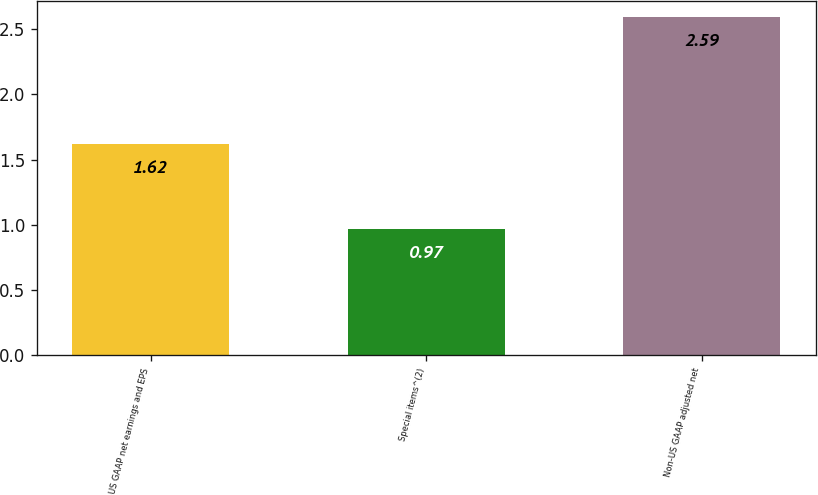Convert chart. <chart><loc_0><loc_0><loc_500><loc_500><bar_chart><fcel>US GAAP net earnings and EPS<fcel>Special items^(2)<fcel>Non-US GAAP adjusted net<nl><fcel>1.62<fcel>0.97<fcel>2.59<nl></chart> 